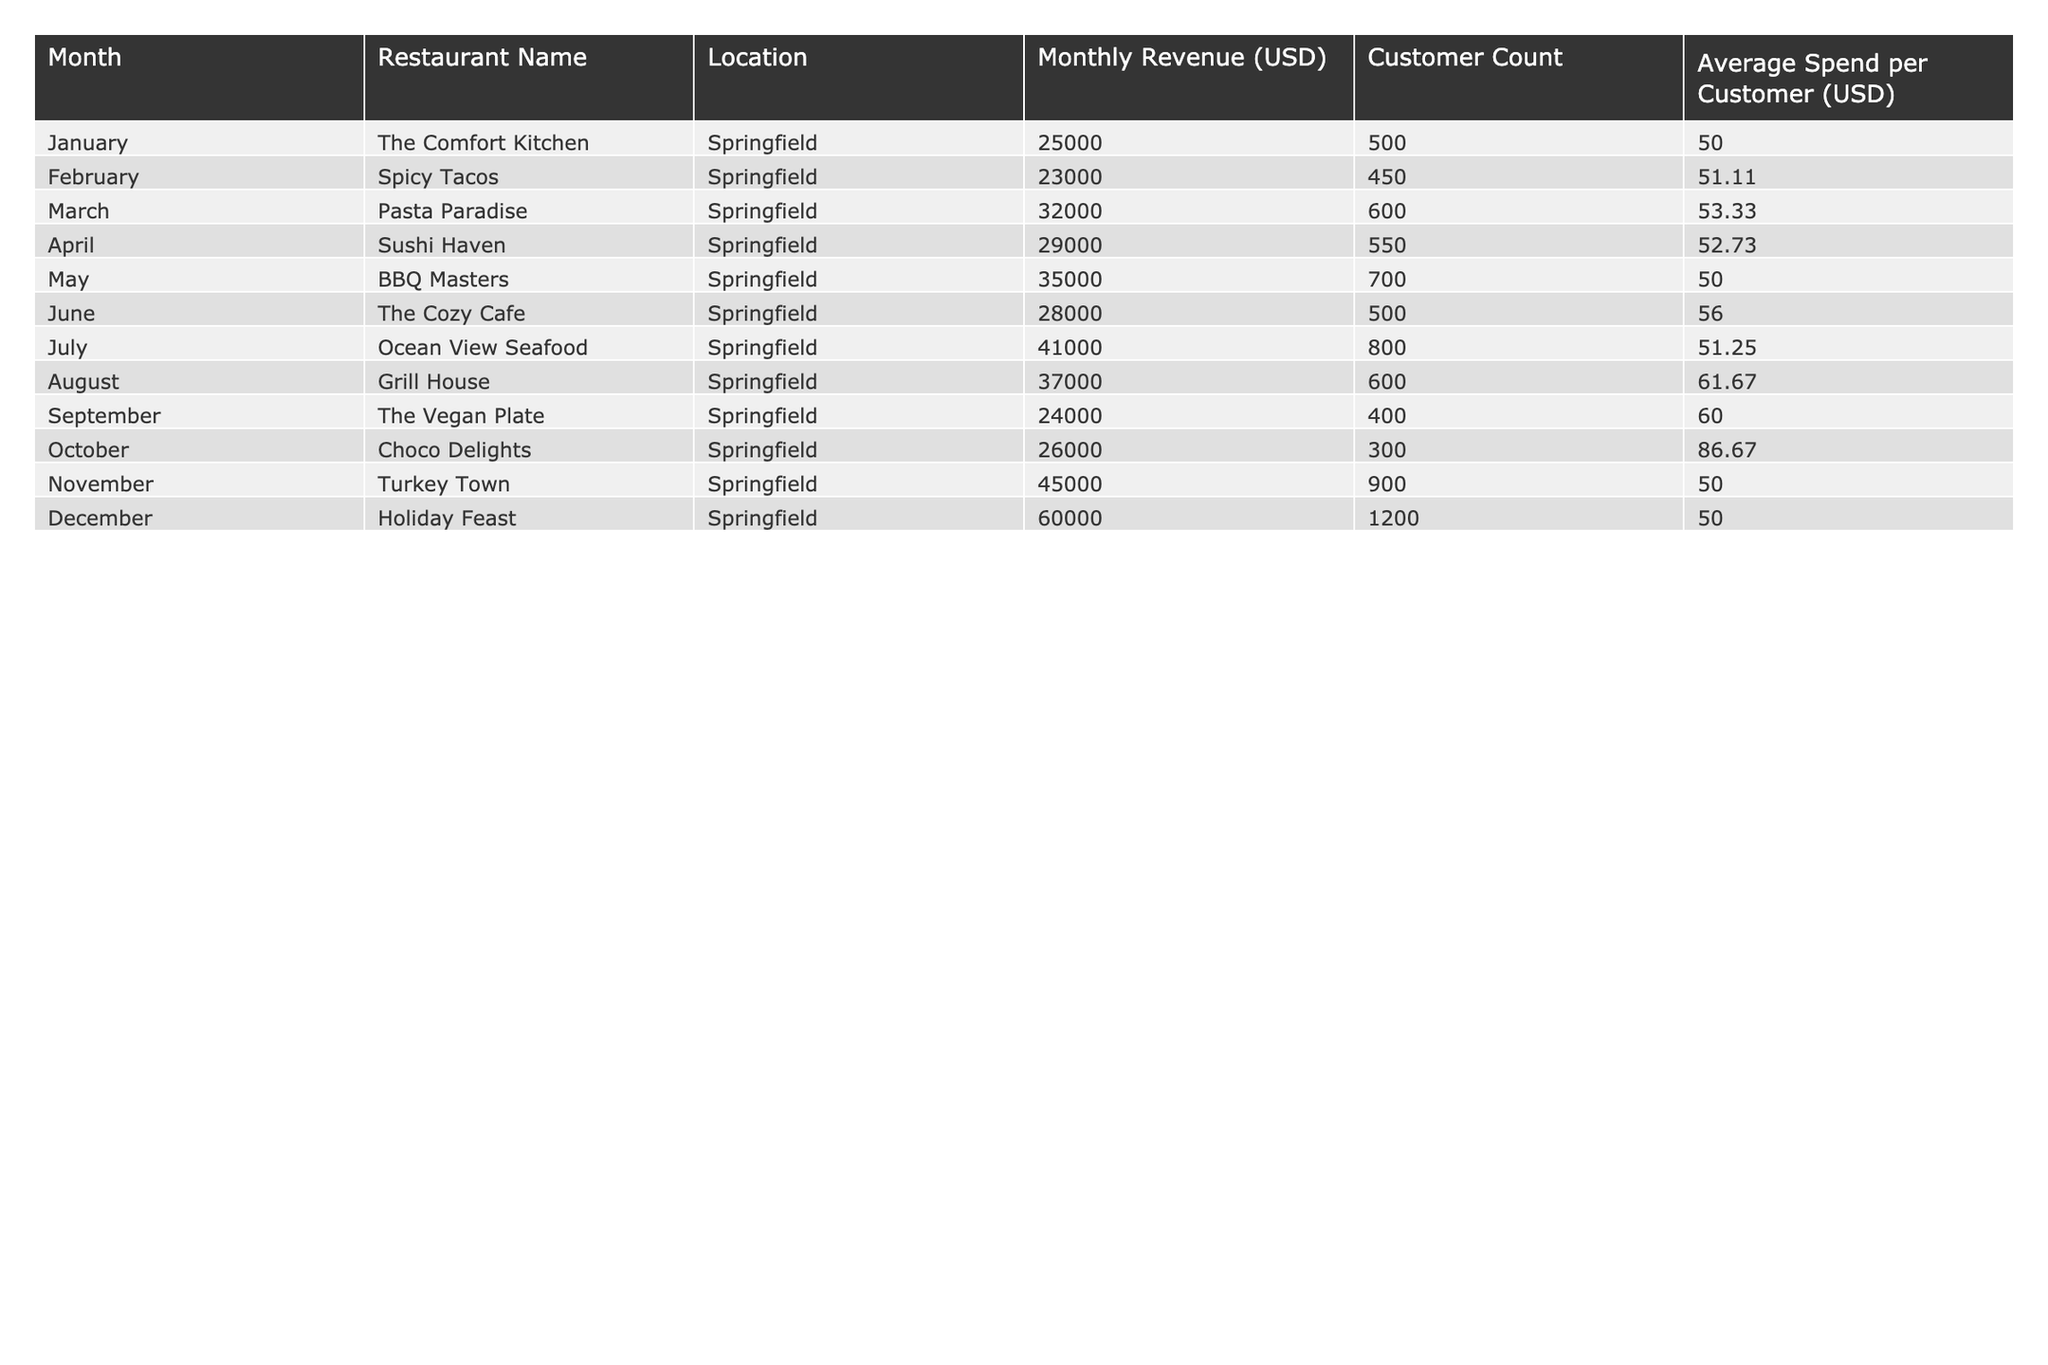What was the highest monthly revenue recorded in 2022? By reviewing the "Monthly Revenue (USD)" column in the table, we can see that the highest value is 60000, which corresponds to December.
Answer: 60000 Which month had the lowest customer count? Looking at the "Customer Count" column, we find that October had the lowest count of 300.
Answer: 300 What is the average monthly revenue across all restaurants in 2022? To find the average, we sum the monthly revenues and divide by the number of months: (25000 + 23000 + 32000 + 29000 + 35000 + 28000 + 41000 + 37000 + 24000 + 26000 + 45000 + 60000) =  427000, and dividing by 12 gives us an average of approximately 35583.33.
Answer: 35583.33 Did any restaurant generate a revenue of more than 40000 during the year? By inspecting the "Monthly Revenue (USD)" column, we see that July (41000), November (45000), and December (60000) all exceeded 40000.
Answer: Yes What was the change in revenue from January to December? January's revenue was 25000 and December's was 60000. The difference is 60000 - 25000 = 35000, indicating an increase.
Answer: 35000 What was the average spend per customer for Spicy Tacos? In the table, the "Average Spend per Customer (USD)" for Spicy Tacos is listed as 51.11.
Answer: 51.11 Which month had the highest increase in revenue compared to the previous month? By reviewing the monthly revenues, we compare the differences: February to March (32000 - 23000 = 9000), April to May (35000 - 29000 = 6000), July to August (37000 - 41000 = -4000), November to December (60000 - 45000 = 15000). Thus the highest increase is from November to December of 15000.
Answer: November to December What was the total customer count for the second half of the year (July to December)? We sum the customer counts from July to December: 800 (July) + 600 (August) + 400 (September) + 300 (October) + 900 (November) + 1200 (December) = 3900.
Answer: 3900 Was the average spend per customer in October higher than in May? The average spend per customer in October is 86.67 and in May is 50.00. Since 86.67 is greater than 50.00, the statement is true.
Answer: Yes What is the total revenue for the first quarter of the year (January to March)? Add the revenues for January, February, and March: 25000 + 23000 + 32000 = 80000.
Answer: 80000 